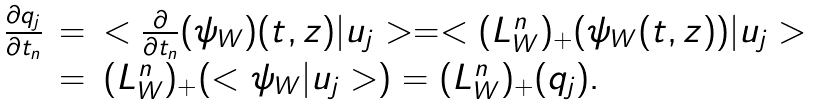<formula> <loc_0><loc_0><loc_500><loc_500>\begin{array} [ h ] { l c l } \frac { \partial q _ { j } } { \partial t _ { n } } & = & < \frac { \partial } { \partial t _ { n } } ( \psi _ { W } ) ( t , z ) | u _ { j } > = < ( L ^ { n } _ { W } ) _ { + } ( \psi _ { W } ( t , z ) ) | u _ { j } > \\ & = & ( L ^ { n } _ { W } ) _ { + } ( < \psi _ { W } | u _ { j } > ) = ( L ^ { n } _ { W } ) _ { + } ( q _ { j } ) . \end{array}</formula> 